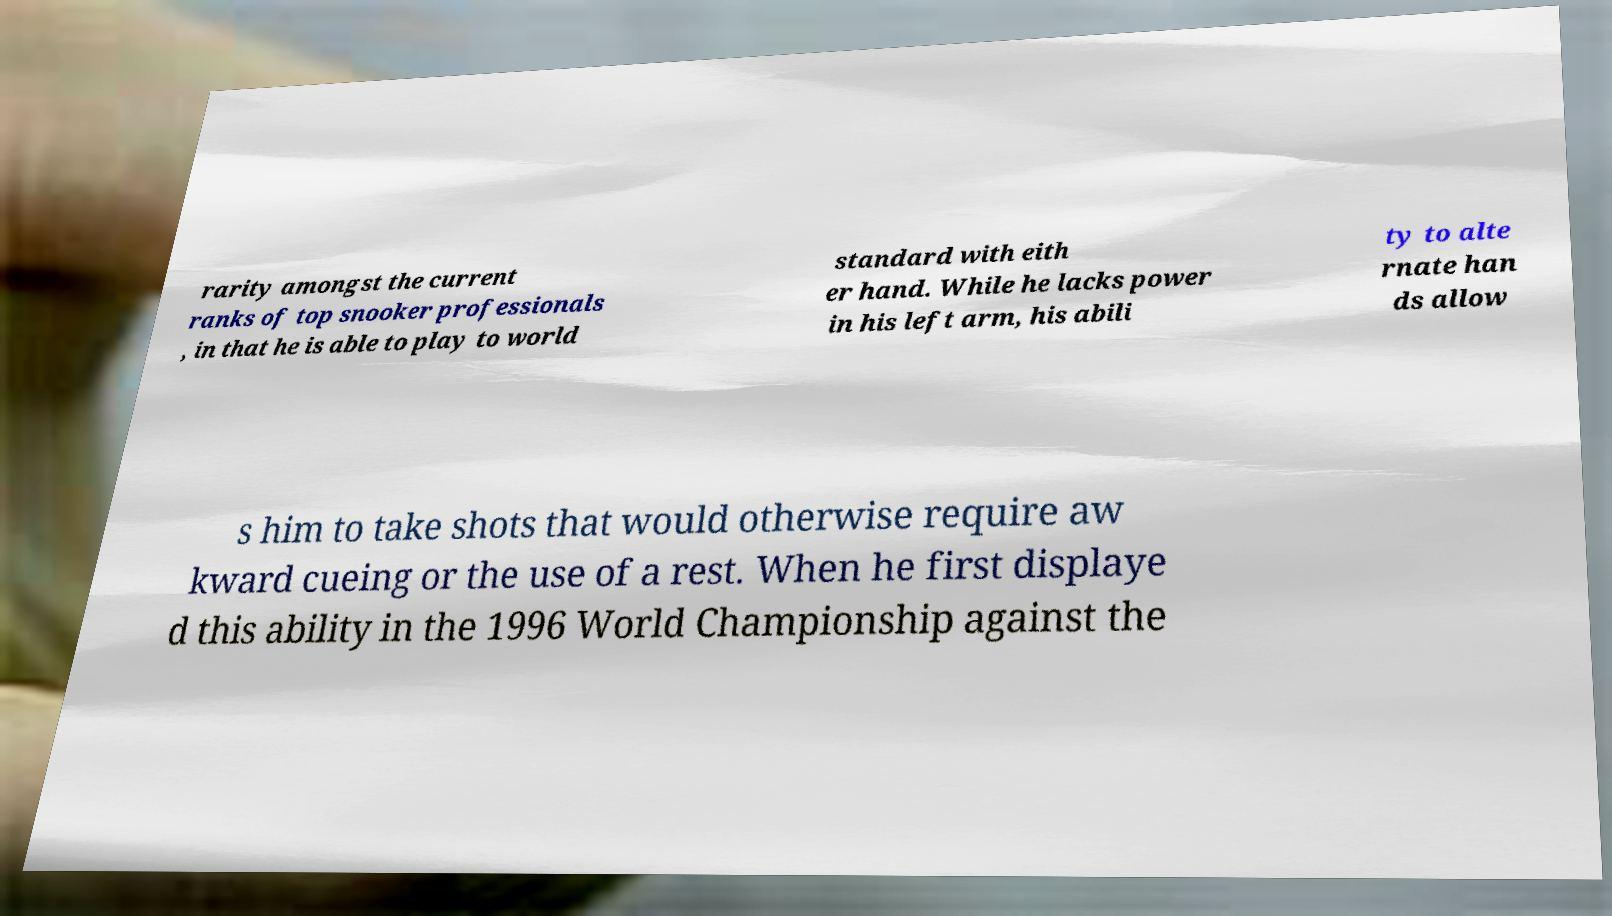Could you extract and type out the text from this image? rarity amongst the current ranks of top snooker professionals , in that he is able to play to world standard with eith er hand. While he lacks power in his left arm, his abili ty to alte rnate han ds allow s him to take shots that would otherwise require aw kward cueing or the use of a rest. When he first displaye d this ability in the 1996 World Championship against the 